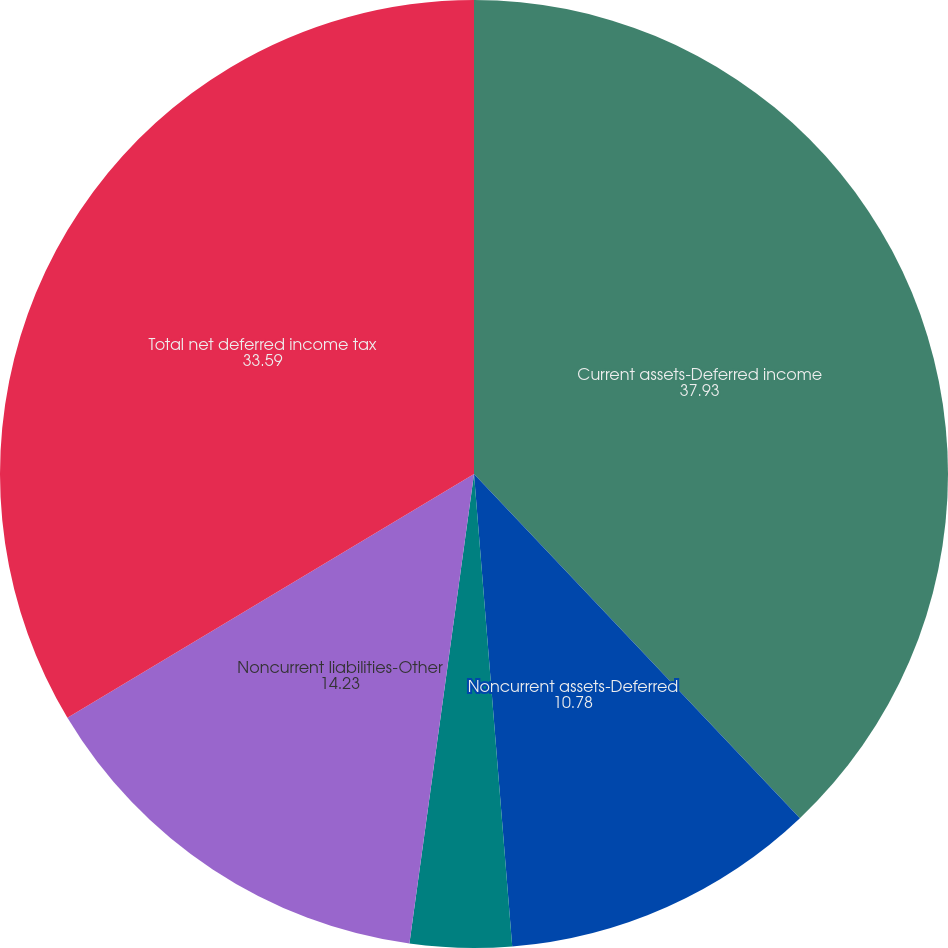Convert chart to OTSL. <chart><loc_0><loc_0><loc_500><loc_500><pie_chart><fcel>Current assets-Deferred income<fcel>Noncurrent assets-Deferred<fcel>Current liabilities-Accrued<fcel>Noncurrent liabilities-Other<fcel>Total net deferred income tax<nl><fcel>37.93%<fcel>10.78%<fcel>3.46%<fcel>14.23%<fcel>33.59%<nl></chart> 